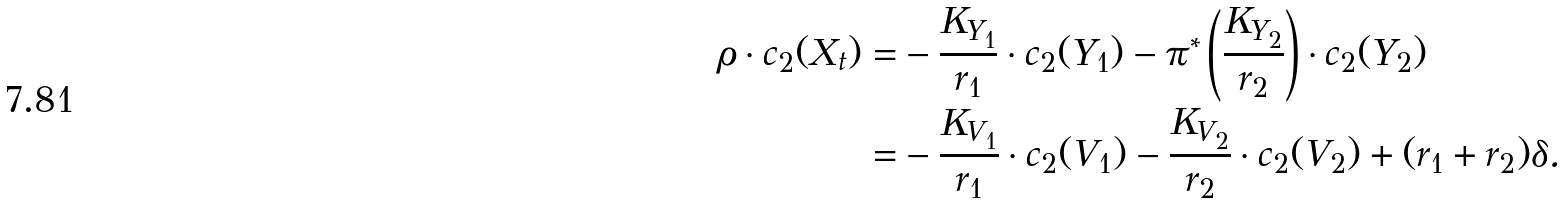<formula> <loc_0><loc_0><loc_500><loc_500>\rho \cdot c _ { 2 } ( X _ { t } ) = & - \frac { K _ { Y _ { 1 } } } { r _ { 1 } } \cdot c _ { 2 } ( Y _ { 1 } ) - \pi ^ { * } \left ( \frac { K _ { Y _ { 2 } } } { r _ { 2 } } \right ) \cdot c _ { 2 } ( Y _ { 2 } ) \\ = & - \frac { K _ { V _ { 1 } } } { r _ { 1 } } \cdot c _ { 2 } ( V _ { 1 } ) - \frac { K _ { V _ { 2 } } } { r _ { 2 } } \cdot c _ { 2 } ( V _ { 2 } ) + ( r _ { 1 } + r _ { 2 } ) \delta .</formula> 